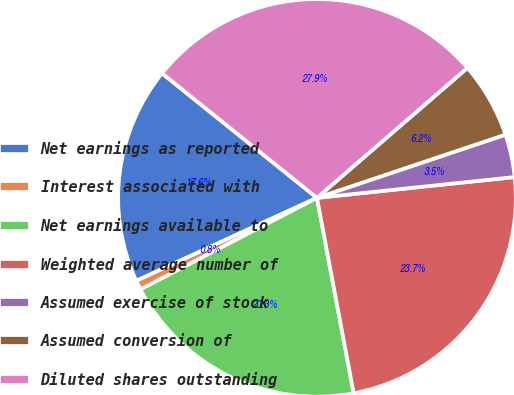<chart> <loc_0><loc_0><loc_500><loc_500><pie_chart><fcel>Net earnings as reported<fcel>Interest associated with<fcel>Net earnings available to<fcel>Weighted average number of<fcel>Assumed exercise of stock<fcel>Assumed conversion of<fcel>Diluted shares outstanding<nl><fcel>17.63%<fcel>0.76%<fcel>20.34%<fcel>23.71%<fcel>3.48%<fcel>6.19%<fcel>27.88%<nl></chart> 